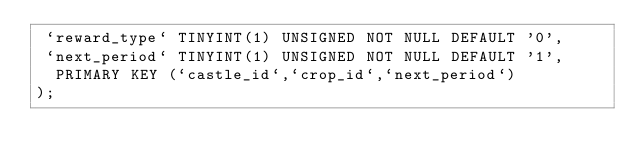Convert code to text. <code><loc_0><loc_0><loc_500><loc_500><_SQL_> `reward_type` TINYINT(1) UNSIGNED NOT NULL DEFAULT '0',
 `next_period` TINYINT(1) UNSIGNED NOT NULL DEFAULT '1',
  PRIMARY KEY (`castle_id`,`crop_id`,`next_period`)
);</code> 